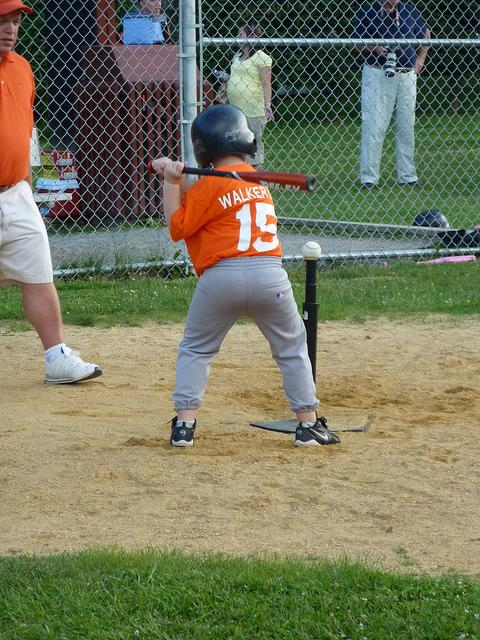What is this kid playing in? Please explain your reasoning. little league. The kid is playing on a little league team. 